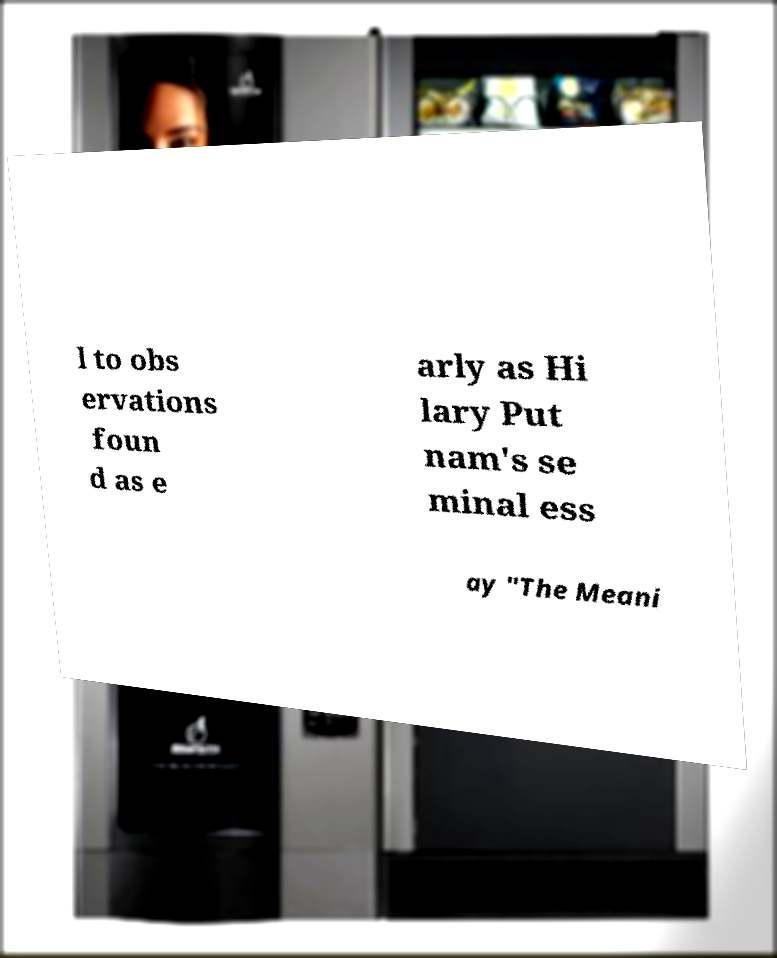Please identify and transcribe the text found in this image. l to obs ervations foun d as e arly as Hi lary Put nam's se minal ess ay "The Meani 